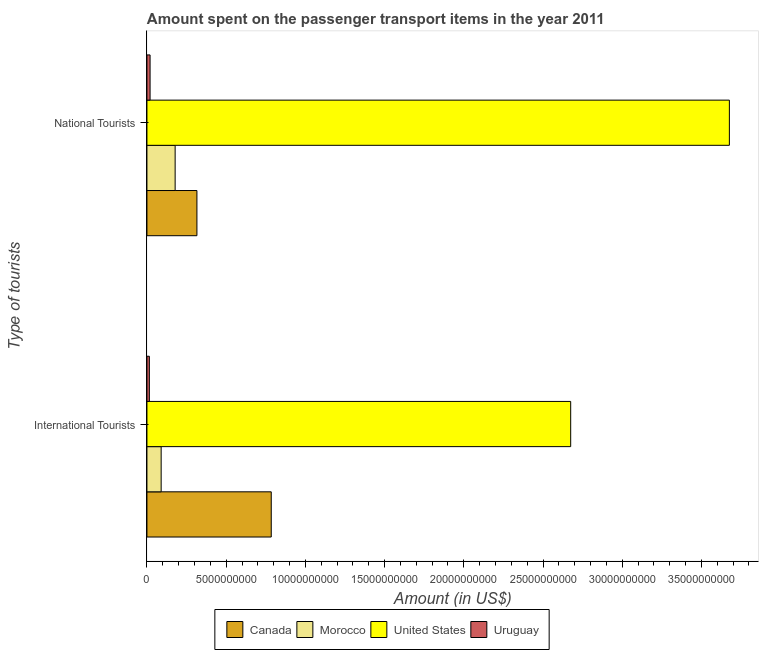How many groups of bars are there?
Keep it short and to the point. 2. Are the number of bars per tick equal to the number of legend labels?
Provide a succinct answer. Yes. Are the number of bars on each tick of the Y-axis equal?
Make the answer very short. Yes. How many bars are there on the 1st tick from the top?
Make the answer very short. 4. How many bars are there on the 1st tick from the bottom?
Make the answer very short. 4. What is the label of the 1st group of bars from the top?
Your response must be concise. National Tourists. What is the amount spent on transport items of national tourists in Canada?
Your answer should be compact. 3.16e+09. Across all countries, what is the maximum amount spent on transport items of national tourists?
Provide a short and direct response. 3.68e+1. Across all countries, what is the minimum amount spent on transport items of national tourists?
Ensure brevity in your answer.  1.98e+08. In which country was the amount spent on transport items of national tourists minimum?
Your answer should be compact. Uruguay. What is the total amount spent on transport items of international tourists in the graph?
Your answer should be very brief. 3.56e+1. What is the difference between the amount spent on transport items of international tourists in Canada and that in Uruguay?
Make the answer very short. 7.69e+09. What is the difference between the amount spent on transport items of national tourists in Morocco and the amount spent on transport items of international tourists in United States?
Provide a short and direct response. -2.50e+1. What is the average amount spent on transport items of national tourists per country?
Ensure brevity in your answer.  1.05e+1. What is the difference between the amount spent on transport items of national tourists and amount spent on transport items of international tourists in Canada?
Your answer should be compact. -4.69e+09. What is the ratio of the amount spent on transport items of international tourists in Uruguay to that in Morocco?
Offer a very short reply. 0.17. In how many countries, is the amount spent on transport items of international tourists greater than the average amount spent on transport items of international tourists taken over all countries?
Provide a short and direct response. 1. What does the 3rd bar from the top in International Tourists represents?
Your answer should be compact. Morocco. What does the 3rd bar from the bottom in National Tourists represents?
Your answer should be very brief. United States. How many bars are there?
Make the answer very short. 8. How many countries are there in the graph?
Your answer should be very brief. 4. Are the values on the major ticks of X-axis written in scientific E-notation?
Your answer should be very brief. No. Does the graph contain any zero values?
Give a very brief answer. No. Where does the legend appear in the graph?
Keep it short and to the point. Bottom center. How are the legend labels stacked?
Your answer should be compact. Horizontal. What is the title of the graph?
Keep it short and to the point. Amount spent on the passenger transport items in the year 2011. Does "Marshall Islands" appear as one of the legend labels in the graph?
Offer a very short reply. No. What is the label or title of the X-axis?
Give a very brief answer. Amount (in US$). What is the label or title of the Y-axis?
Provide a short and direct response. Type of tourists. What is the Amount (in US$) in Canada in International Tourists?
Your answer should be compact. 7.85e+09. What is the Amount (in US$) in Morocco in International Tourists?
Provide a short and direct response. 8.97e+08. What is the Amount (in US$) of United States in International Tourists?
Offer a terse response. 2.67e+1. What is the Amount (in US$) in Uruguay in International Tourists?
Ensure brevity in your answer.  1.53e+08. What is the Amount (in US$) in Canada in National Tourists?
Make the answer very short. 3.16e+09. What is the Amount (in US$) in Morocco in National Tourists?
Ensure brevity in your answer.  1.78e+09. What is the Amount (in US$) in United States in National Tourists?
Your answer should be compact. 3.68e+1. What is the Amount (in US$) of Uruguay in National Tourists?
Give a very brief answer. 1.98e+08. Across all Type of tourists, what is the maximum Amount (in US$) in Canada?
Your answer should be compact. 7.85e+09. Across all Type of tourists, what is the maximum Amount (in US$) of Morocco?
Offer a terse response. 1.78e+09. Across all Type of tourists, what is the maximum Amount (in US$) in United States?
Make the answer very short. 3.68e+1. Across all Type of tourists, what is the maximum Amount (in US$) in Uruguay?
Your response must be concise. 1.98e+08. Across all Type of tourists, what is the minimum Amount (in US$) of Canada?
Your answer should be very brief. 3.16e+09. Across all Type of tourists, what is the minimum Amount (in US$) in Morocco?
Offer a terse response. 8.97e+08. Across all Type of tourists, what is the minimum Amount (in US$) of United States?
Ensure brevity in your answer.  2.67e+1. Across all Type of tourists, what is the minimum Amount (in US$) of Uruguay?
Your response must be concise. 1.53e+08. What is the total Amount (in US$) of Canada in the graph?
Keep it short and to the point. 1.10e+1. What is the total Amount (in US$) in Morocco in the graph?
Your response must be concise. 2.68e+09. What is the total Amount (in US$) of United States in the graph?
Offer a very short reply. 6.35e+1. What is the total Amount (in US$) in Uruguay in the graph?
Give a very brief answer. 3.51e+08. What is the difference between the Amount (in US$) in Canada in International Tourists and that in National Tourists?
Your answer should be compact. 4.69e+09. What is the difference between the Amount (in US$) in Morocco in International Tourists and that in National Tourists?
Make the answer very short. -8.83e+08. What is the difference between the Amount (in US$) of United States in International Tourists and that in National Tourists?
Offer a very short reply. -1.00e+1. What is the difference between the Amount (in US$) of Uruguay in International Tourists and that in National Tourists?
Your response must be concise. -4.50e+07. What is the difference between the Amount (in US$) in Canada in International Tourists and the Amount (in US$) in Morocco in National Tourists?
Your response must be concise. 6.07e+09. What is the difference between the Amount (in US$) in Canada in International Tourists and the Amount (in US$) in United States in National Tourists?
Keep it short and to the point. -2.89e+1. What is the difference between the Amount (in US$) in Canada in International Tourists and the Amount (in US$) in Uruguay in National Tourists?
Your response must be concise. 7.65e+09. What is the difference between the Amount (in US$) in Morocco in International Tourists and the Amount (in US$) in United States in National Tourists?
Offer a very short reply. -3.59e+1. What is the difference between the Amount (in US$) of Morocco in International Tourists and the Amount (in US$) of Uruguay in National Tourists?
Provide a succinct answer. 6.99e+08. What is the difference between the Amount (in US$) of United States in International Tourists and the Amount (in US$) of Uruguay in National Tourists?
Keep it short and to the point. 2.65e+1. What is the average Amount (in US$) of Canada per Type of tourists?
Offer a very short reply. 5.50e+09. What is the average Amount (in US$) in Morocco per Type of tourists?
Ensure brevity in your answer.  1.34e+09. What is the average Amount (in US$) in United States per Type of tourists?
Offer a very short reply. 3.18e+1. What is the average Amount (in US$) in Uruguay per Type of tourists?
Keep it short and to the point. 1.76e+08. What is the difference between the Amount (in US$) of Canada and Amount (in US$) of Morocco in International Tourists?
Offer a terse response. 6.95e+09. What is the difference between the Amount (in US$) in Canada and Amount (in US$) in United States in International Tourists?
Keep it short and to the point. -1.89e+1. What is the difference between the Amount (in US$) in Canada and Amount (in US$) in Uruguay in International Tourists?
Give a very brief answer. 7.69e+09. What is the difference between the Amount (in US$) of Morocco and Amount (in US$) of United States in International Tourists?
Your response must be concise. -2.58e+1. What is the difference between the Amount (in US$) of Morocco and Amount (in US$) of Uruguay in International Tourists?
Provide a succinct answer. 7.44e+08. What is the difference between the Amount (in US$) in United States and Amount (in US$) in Uruguay in International Tourists?
Ensure brevity in your answer.  2.66e+1. What is the difference between the Amount (in US$) of Canada and Amount (in US$) of Morocco in National Tourists?
Offer a terse response. 1.38e+09. What is the difference between the Amount (in US$) of Canada and Amount (in US$) of United States in National Tourists?
Offer a very short reply. -3.36e+1. What is the difference between the Amount (in US$) of Canada and Amount (in US$) of Uruguay in National Tourists?
Make the answer very short. 2.96e+09. What is the difference between the Amount (in US$) of Morocco and Amount (in US$) of United States in National Tourists?
Your response must be concise. -3.50e+1. What is the difference between the Amount (in US$) of Morocco and Amount (in US$) of Uruguay in National Tourists?
Give a very brief answer. 1.58e+09. What is the difference between the Amount (in US$) of United States and Amount (in US$) of Uruguay in National Tourists?
Your answer should be very brief. 3.66e+1. What is the ratio of the Amount (in US$) in Canada in International Tourists to that in National Tourists?
Your answer should be very brief. 2.49. What is the ratio of the Amount (in US$) of Morocco in International Tourists to that in National Tourists?
Your answer should be very brief. 0.5. What is the ratio of the Amount (in US$) in United States in International Tourists to that in National Tourists?
Offer a very short reply. 0.73. What is the ratio of the Amount (in US$) of Uruguay in International Tourists to that in National Tourists?
Keep it short and to the point. 0.77. What is the difference between the highest and the second highest Amount (in US$) of Canada?
Keep it short and to the point. 4.69e+09. What is the difference between the highest and the second highest Amount (in US$) in Morocco?
Give a very brief answer. 8.83e+08. What is the difference between the highest and the second highest Amount (in US$) in United States?
Your answer should be compact. 1.00e+1. What is the difference between the highest and the second highest Amount (in US$) in Uruguay?
Keep it short and to the point. 4.50e+07. What is the difference between the highest and the lowest Amount (in US$) of Canada?
Make the answer very short. 4.69e+09. What is the difference between the highest and the lowest Amount (in US$) in Morocco?
Give a very brief answer. 8.83e+08. What is the difference between the highest and the lowest Amount (in US$) of United States?
Your response must be concise. 1.00e+1. What is the difference between the highest and the lowest Amount (in US$) of Uruguay?
Give a very brief answer. 4.50e+07. 